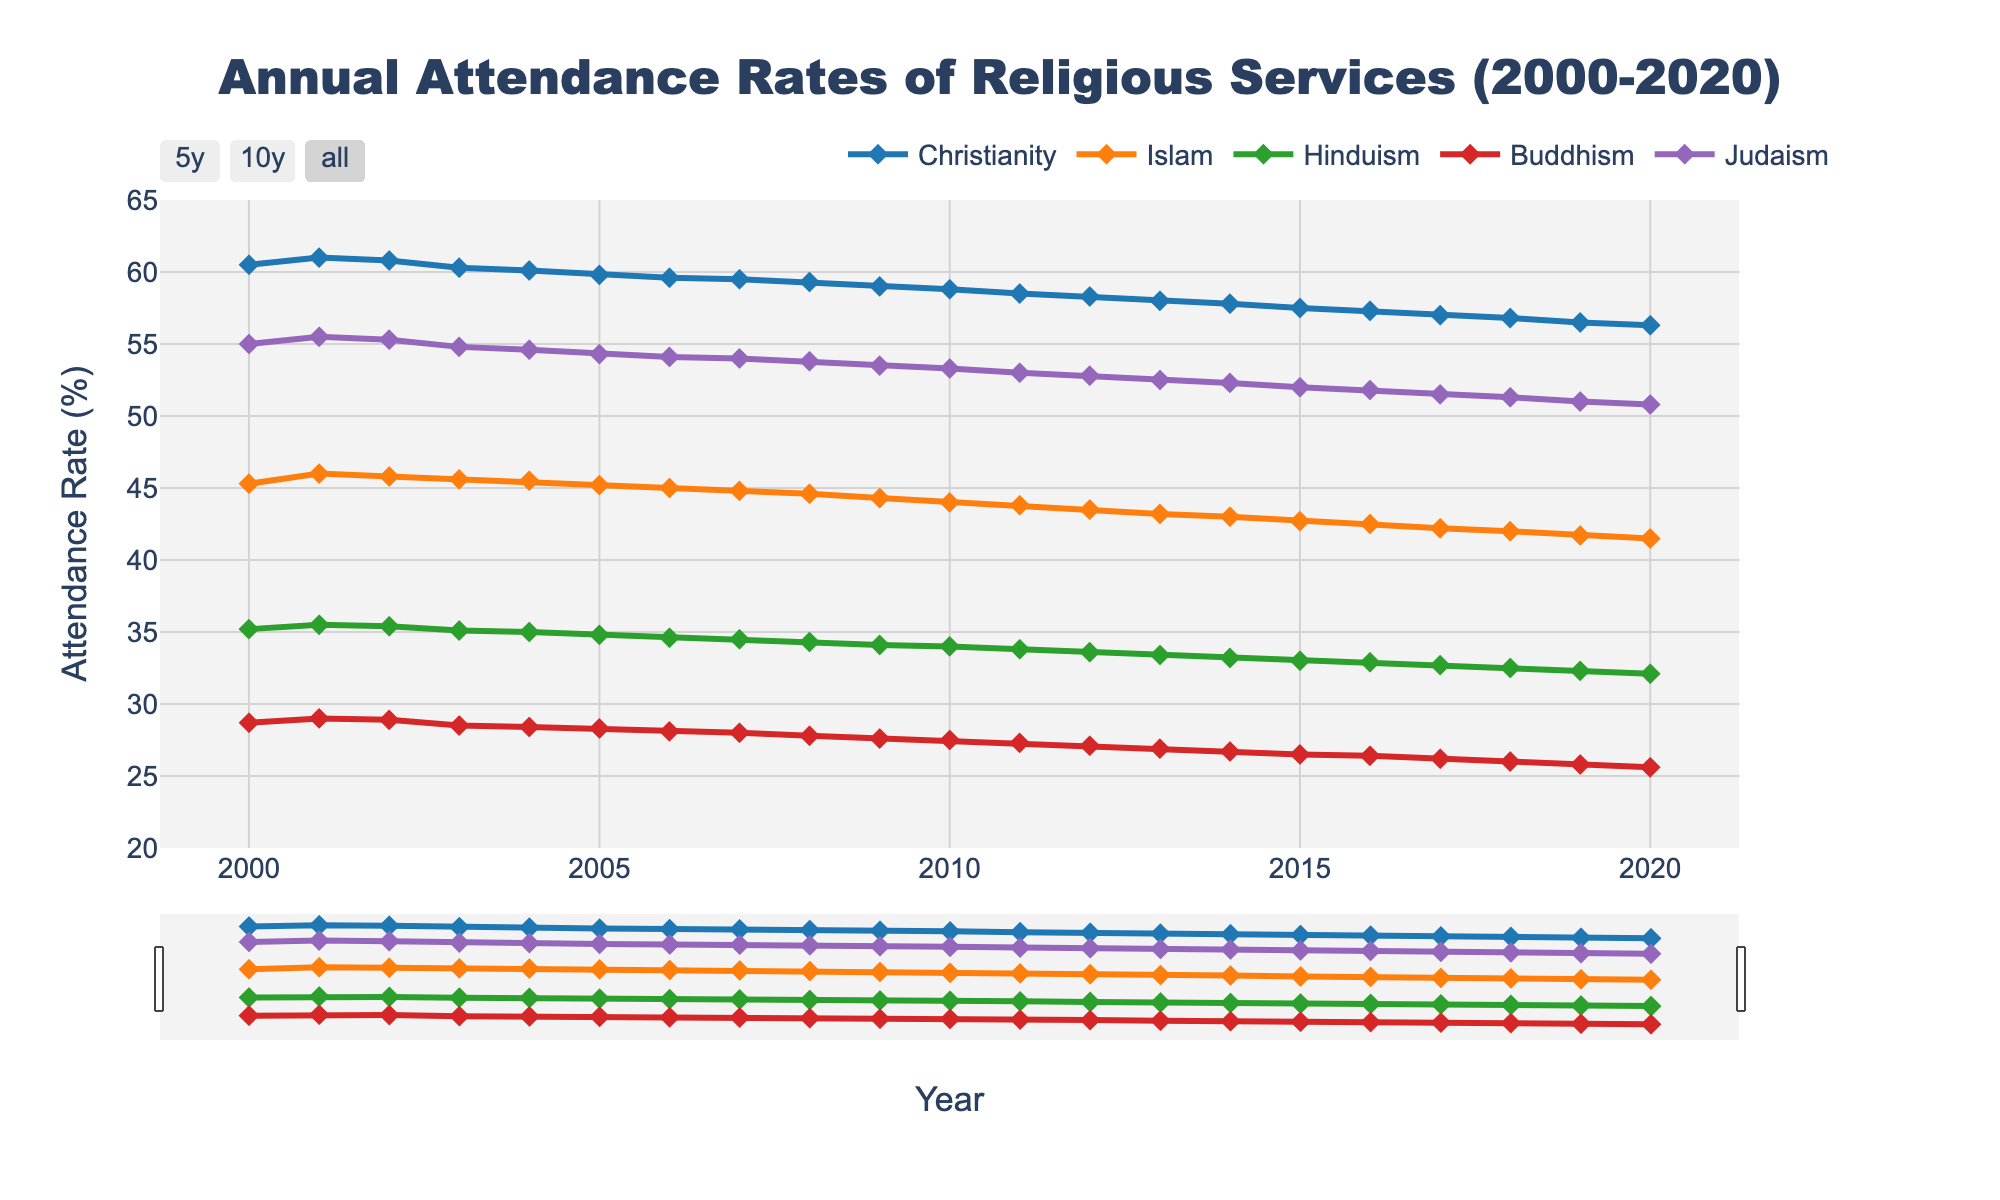What's the title of the figure? The title of the figure is displayed prominently at the top. It states "Annual Attendance Rates of Religious Services (2000-2020)"
Answer: Annual Attendance Rates of Religious Services (2000-2020) Which faith has the highest attendance rate in the year 2000? By looking at the attendance rates for the year 2000 in the figure, we see that Christianity has the highest rate at 60.5%
Answer: Christianity How did the attendance rate of Judaism change from 2000 to 2020? Observing the Judaism line from 2000 to 2020, we see a gradual decrease from 55.0% to 50.8%.
Answer: Decreased Between 2000 and 2020, which faith had the smallest decline in attendance rates? Comparing the decline across all faiths, Hinduism dropped from 35.2% to 32.1%, representing the smallest decline.
Answer: Hinduism Which faith had a consistently downward trend throughout the entire period? Examining the slopes of the lines, the attendance rates for all the faiths show a downward trend, but Christianity has the most consistent, gradual decline from 60.5% to 56.3%.
Answer: Christianity What is the average attendance rate of Buddhism over the two decades? Sum the annual attendance rates for Buddhism from each year and divide by the total number of years (21). The rates are: 28.7, 29.0, 28.9, 28.5, 28.4, 28.3, 28.1, 28.0, 27.8, 27.6, 27.5, 27.3, 27.1, 26.9, 26.7, 26.5, 26.4, 26.2, 26.0, 25.8, 25.6. Average = (28.7 + ... + 25.6) / 21.
Answer: 27.3 Which year saw the highest attendance rate for Buddhism? The highest point on the Buddhism line occurs in 2001 with a rate of 29.0%.
Answer: 2001 What is the range of attendance rates for Islam during the time period? Subtract the lowest rate (41.5% in 2020) from the highest rate (46.0% in 2001).
Answer: 4.5% Which faith had the steepest decline in attendance rate between 2000 and 2010? Calculate the difference for each faith over this period, then identify the steepest decline: Christianity (60.5 - 58.8 = 1.7), Islam (45.3 - 44.0 = 1.3), Hinduism (35.2 - 34.0 = 1.2), Buddhism (28.7 - 27.5 = 1.2), Judaism (55.0 - 53.3 = 1.7). The steepest declines are Christianity and Judaism.
Answer: Christianity and Judaism 